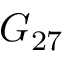Convert formula to latex. <formula><loc_0><loc_0><loc_500><loc_500>G _ { 2 7 }</formula> 